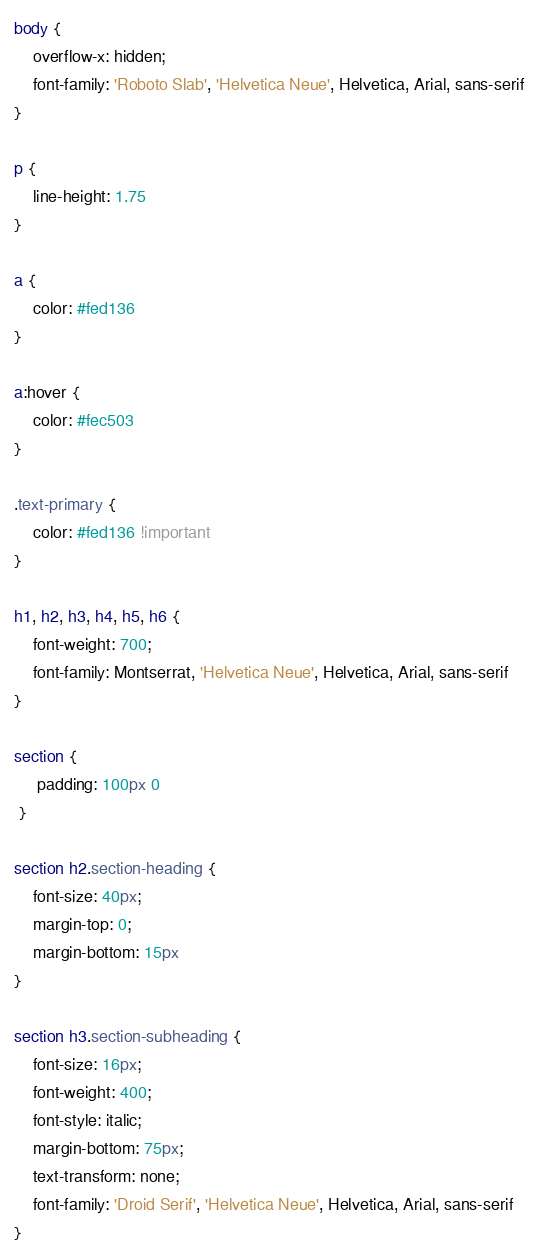Convert code to text. <code><loc_0><loc_0><loc_500><loc_500><_CSS_>body {
    overflow-x: hidden;
    font-family: 'Roboto Slab', 'Helvetica Neue', Helvetica, Arial, sans-serif
}

p {
    line-height: 1.75
}

a {
    color: #fed136
}

a:hover {
    color: #fec503
}

.text-primary {
    color: #fed136 !important
}

h1, h2, h3, h4, h5, h6 {
    font-weight: 700;
    font-family: Montserrat, 'Helvetica Neue', Helvetica, Arial, sans-serif
}

section {
     padding: 100px 0
 }

section h2.section-heading {
    font-size: 40px;
    margin-top: 0;
    margin-bottom: 15px
}

section h3.section-subheading {
    font-size: 16px;
    font-weight: 400;
    font-style: italic;
    margin-bottom: 75px;
    text-transform: none;
    font-family: 'Droid Serif', 'Helvetica Neue', Helvetica, Arial, sans-serif
}
</code> 